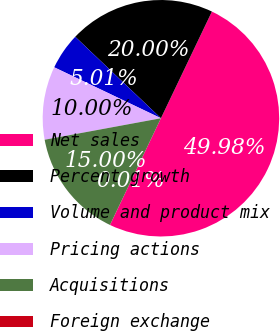Convert chart to OTSL. <chart><loc_0><loc_0><loc_500><loc_500><pie_chart><fcel>Net sales<fcel>Percent growth<fcel>Volume and product mix<fcel>Pricing actions<fcel>Acquisitions<fcel>Foreign exchange<nl><fcel>49.99%<fcel>20.0%<fcel>5.01%<fcel>10.0%<fcel>15.0%<fcel>0.01%<nl></chart> 